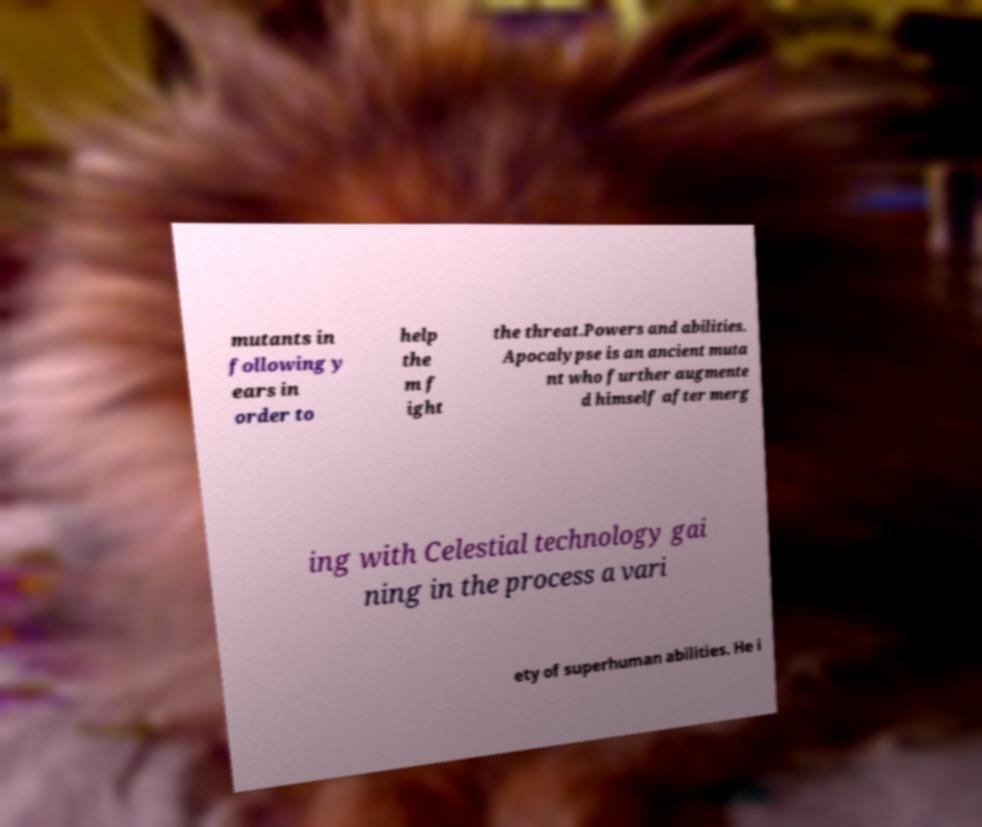What messages or text are displayed in this image? I need them in a readable, typed format. mutants in following y ears in order to help the m f ight the threat.Powers and abilities. Apocalypse is an ancient muta nt who further augmente d himself after merg ing with Celestial technology gai ning in the process a vari ety of superhuman abilities. He i 